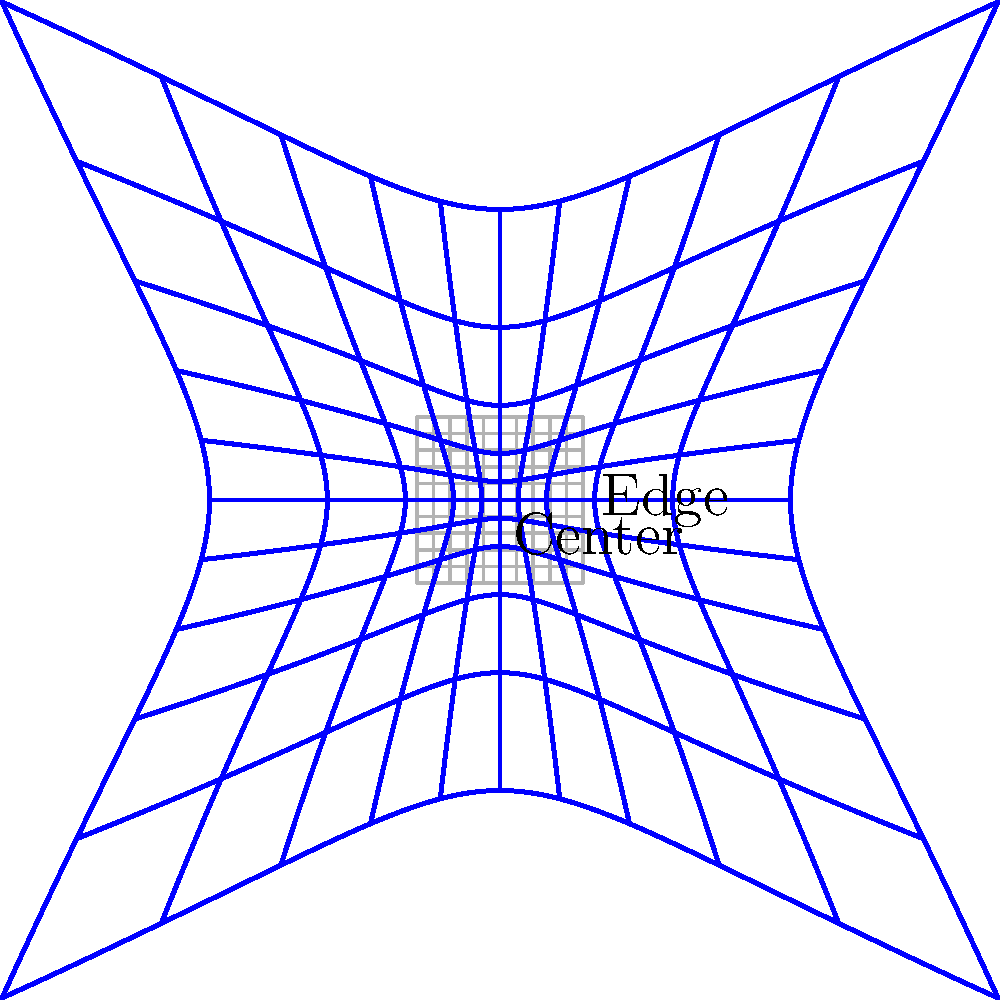In wide-angle photography, lens distortion often follows a specific pattern. Based on the diagram, which shows both an undistorted grid (gray) and a distorted grid (blue), what type of distortion is predominantly illustrated, and how does it affect the image topology? To answer this question, let's analyze the diagram step-by-step:

1. Observe the undistorted grid (gray lines):
   - It forms a regular, evenly-spaced rectangular grid.
   - This represents how the image would appear without any lens distortion.

2. Examine the distorted grid (blue lines):
   - The lines are curved, especially towards the edges of the frame.
   - The distortion increases as we move away from the center.

3. Compare the center and edges:
   - At the center, the distortion is minimal. The blue lines almost align with the gray lines.
   - Towards the edges, the blue lines bulge outwards significantly.

4. Analyze the pattern:
   - The distortion is symmetrical around the center.
   - Straight lines in the original scene (represented by gray lines) become curved, bowing outwards.

5. Identify the distortion type:
   - This pattern is characteristic of barrel distortion, a common type in wide-angle lenses.
   - Barrel distortion causes straight lines to bow outwards, as if wrapped around a barrel.

6. Effect on image topology:
   - The image appears to bulge outwards, especially at the edges and corners.
   - Objects near the edges of the frame appear stretched and larger than they would in reality.
   - Straight lines, particularly near the edges, appear curved.
   - The field of view appears wider than it actually is, especially at the periphery.

In wide-angle photography, this distortion can be both a challenge and a creative tool, depending on the photographer's intent and the subject matter.
Answer: Barrel distortion; causes outward bulging, stretching edges/corners, and curving straight lines. 